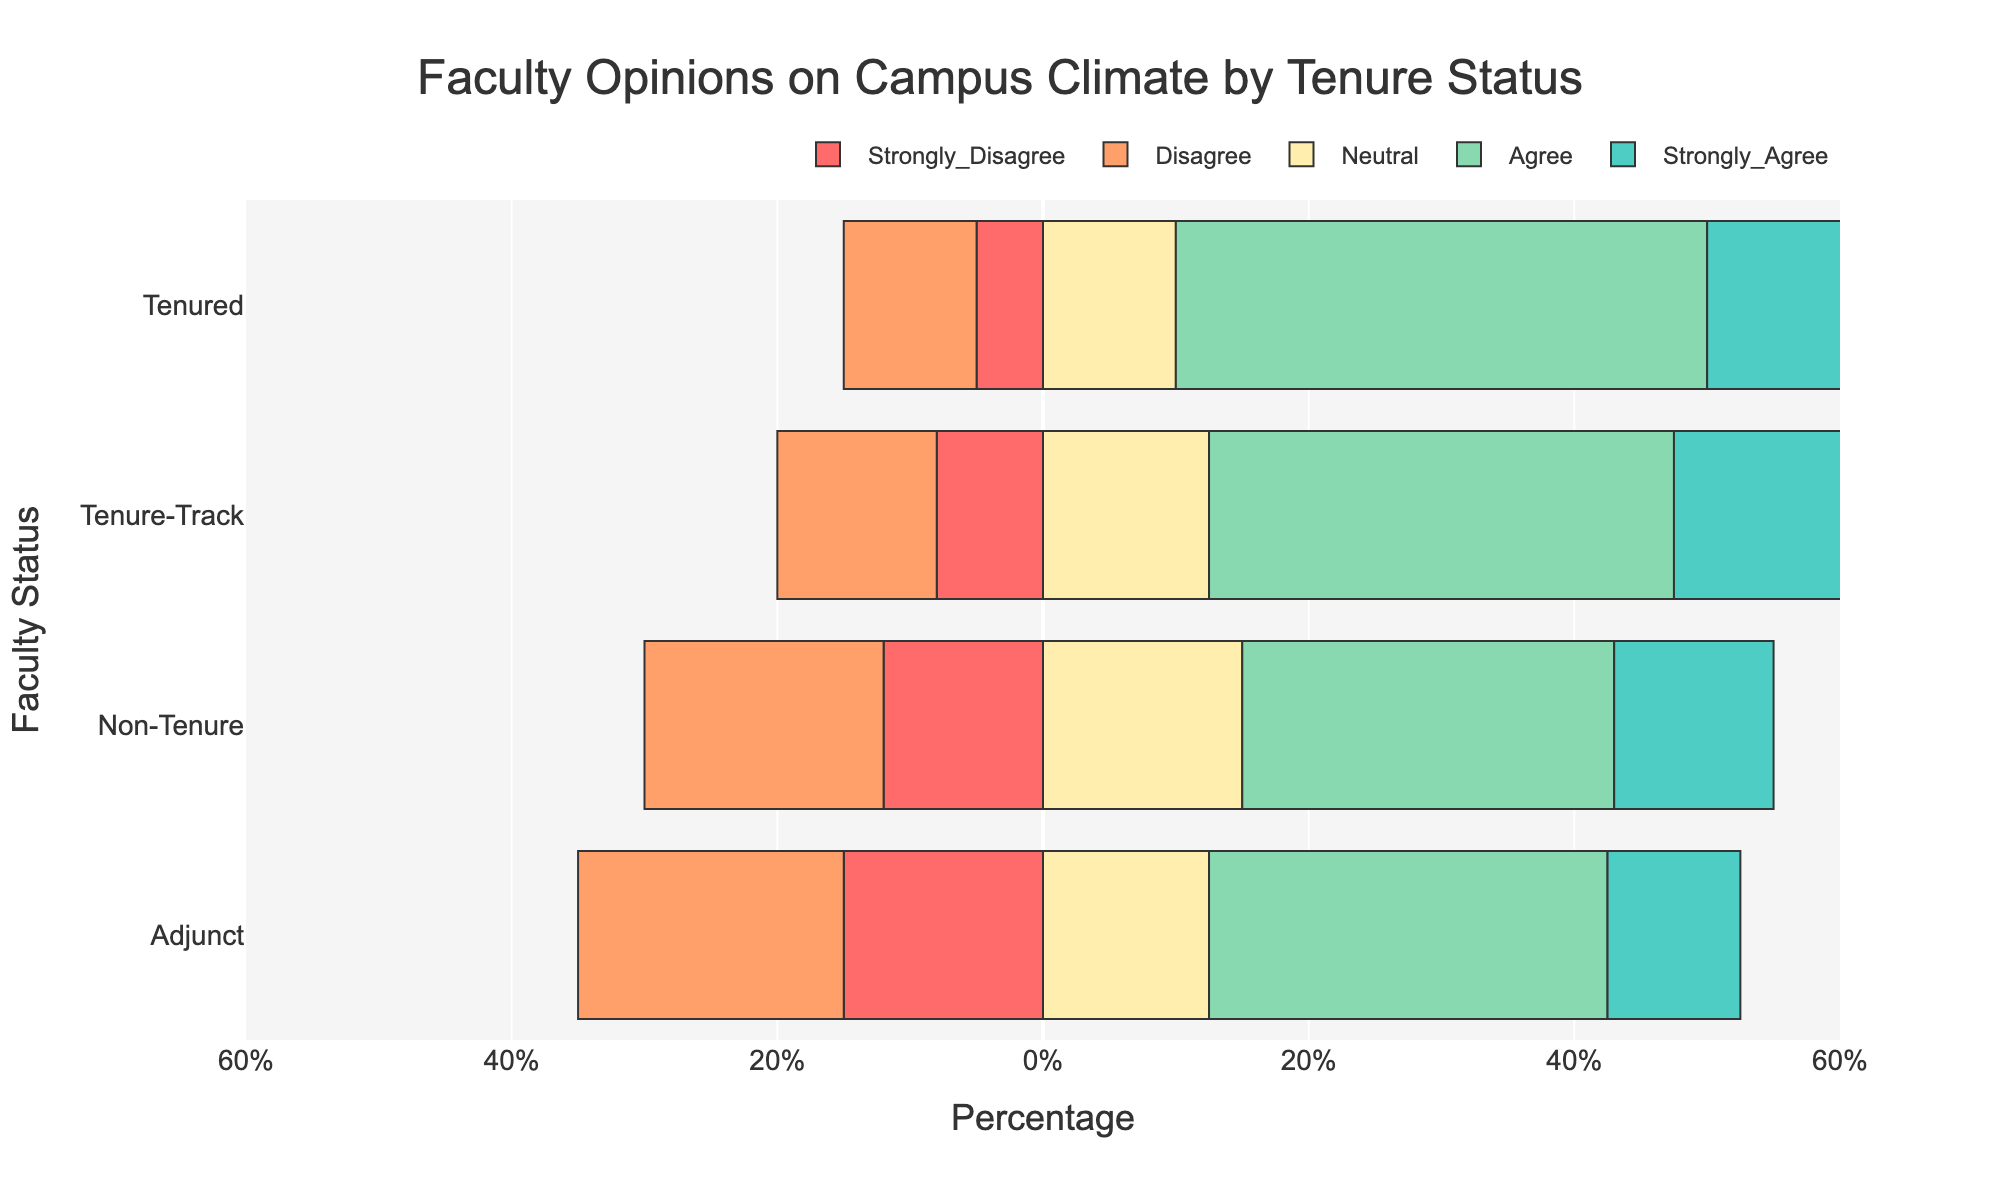What percentage of tenured faculty members agree or strongly agree with the campus climate? Tenured faculty agreeing or strongly agreeing can be found by adding the percentages from the "Agree" and "Strongly Agree" categories. For tenured faculty, 40% agree and 25% strongly agree.
Answer: 65% Which faculty status group shows the highest percentage of strong disagreement with the campus climate? The "Strongly Disagree" percentages need to be compared across all groups. Tenured: 5%, Tenure-Track: 8%, Non-Tenure: 12%, Adjunct: 15%. The highest percentage is for Adjunct faculty.
Answer: Adjunct Is neutrality (neutral perception) more common among Tenure-Track or Non-Tenure faculty? Examining the "Neutral" category percentages for both groups: Tenure-Track is 25%, Non-Tenure is 30%. Thus, it is more common among Non-Tenure faculty.
Answer: Non-Tenure In general, do Non-Tenure faculty members have a more negative or positive view of the campus climate? Summing up the negative responses ("Strongly Disagree" and "Disagree") for Non-Tenure: 12% + 18% = 30%. Summing up the positive responses ("Agree" and "Strongly Agree"): 28% + 12% = 40%. Positive views are more prevalent.
Answer: Positive What is the difference in the percentage between Tenured and Adjunct faculty who strongly agree on the campus climate? The "Strongly Agree" percentages for Tenured is 25% and for Adjunct is 10%. The difference is calculated as 25% - 10%.
Answer: 15% How does the percentage of faculty members who strongly disagree compare between Tenure-Track and Non-Tenure faculty? The "Strongly Disagree" percentages are 8% for Tenure-Track and 12% for Non-Tenure. Comparing these values shows the Non-Tenure percentage is higher.
Answer: Higher for Non-Tenure faculty Which group has the lowest percentage of positive perceptions (agree and strongly agree combined) about the campus climate? Sum the percentages for "Agree" and "Strongly Agree" for each group: Tenured (40% + 25%), Tenure-Track (35% + 20%), Non-Tenure (28% + 12%), Adjunct (30% + 10%). The lowest combined value is for Adjunct faculty.
Answer: Adjunct Are Neutral perceptions greater than Agree (but not Strongly Agree) perceptions within the Non-Tenure faculty group? Non-Tenure "Neutral" is 30% and "Agree" is 28%. Since 30% > 28%, Neutral perceptions are greater than Agree.
Answer: Yes 